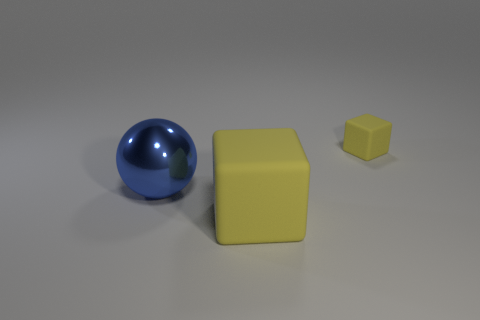Add 3 cubes. How many objects exist? 6 Subtract all cubes. How many objects are left? 1 Subtract 0 blue cubes. How many objects are left? 3 Subtract all matte cubes. Subtract all big brown metallic cubes. How many objects are left? 1 Add 1 matte cubes. How many matte cubes are left? 3 Add 1 large gray rubber balls. How many large gray rubber balls exist? 1 